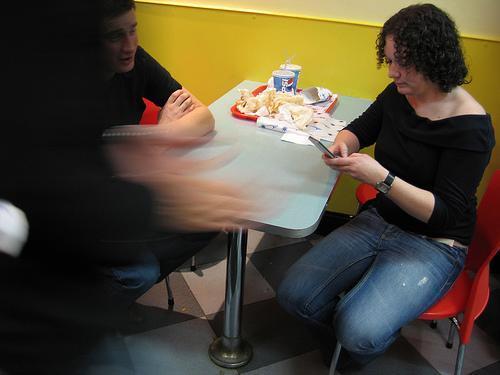How many people are sitting?
Give a very brief answer. 2. 